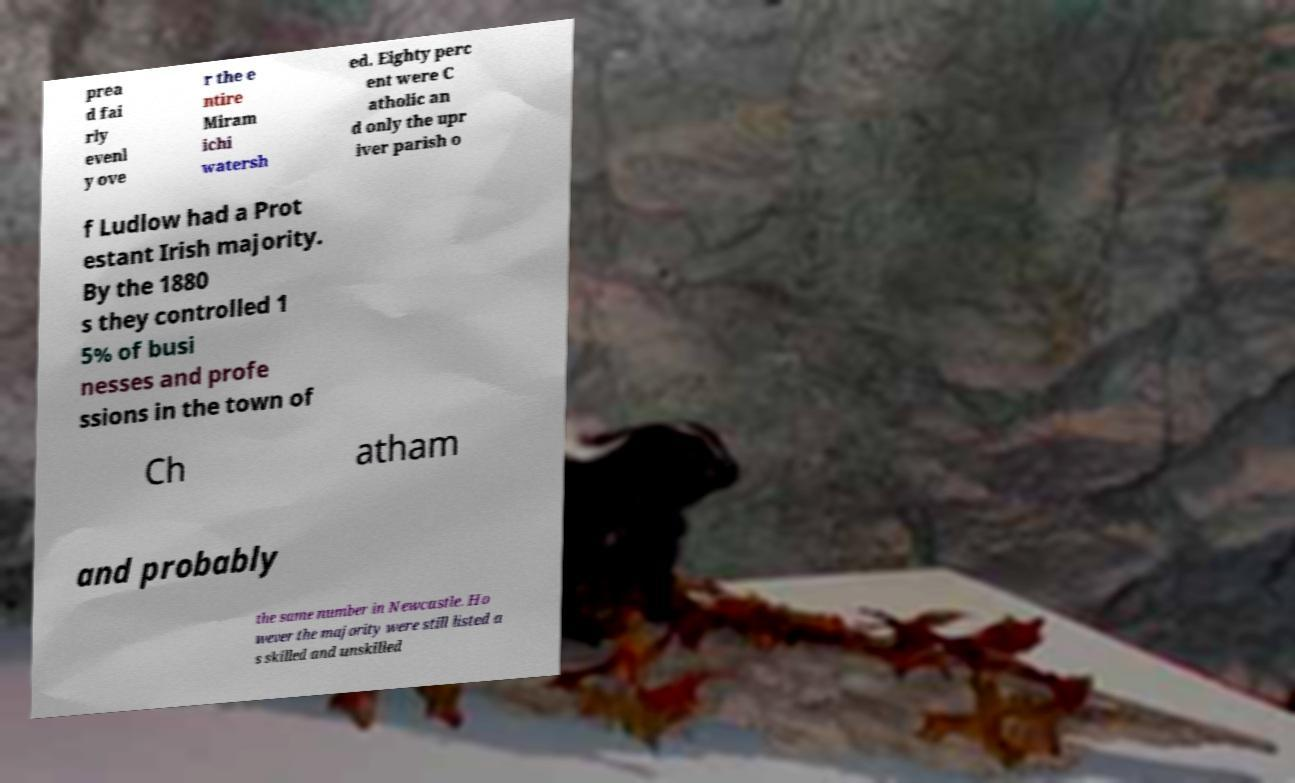Please read and relay the text visible in this image. What does it say? prea d fai rly evenl y ove r the e ntire Miram ichi watersh ed. Eighty perc ent were C atholic an d only the upr iver parish o f Ludlow had a Prot estant Irish majority. By the 1880 s they controlled 1 5% of busi nesses and profe ssions in the town of Ch atham and probably the same number in Newcastle. Ho wever the majority were still listed a s skilled and unskilled 